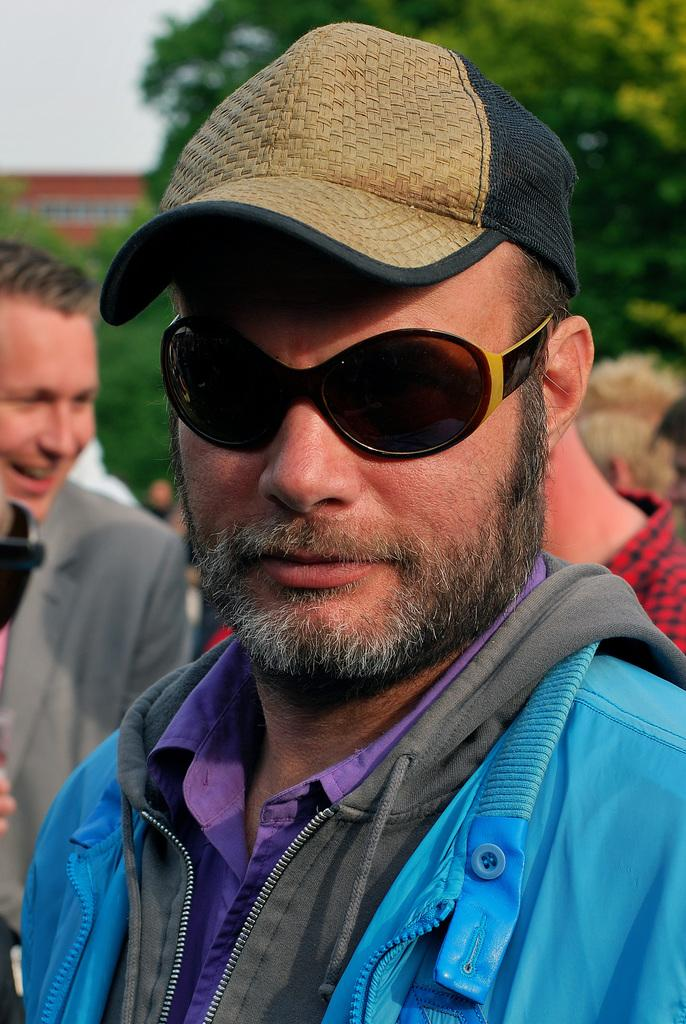What is the person in the foreground of the image wearing? The person in the image is wearing a cap. Are there any other people visible in the image? Yes, there are other people standing behind the person with the cap. What can be seen in the background of the image? There are trees, a building, and the sky visible in the background of the image. How many things can be seen on the hill in the image? There is no hill present in the image, so it is not possible to answer that question. 